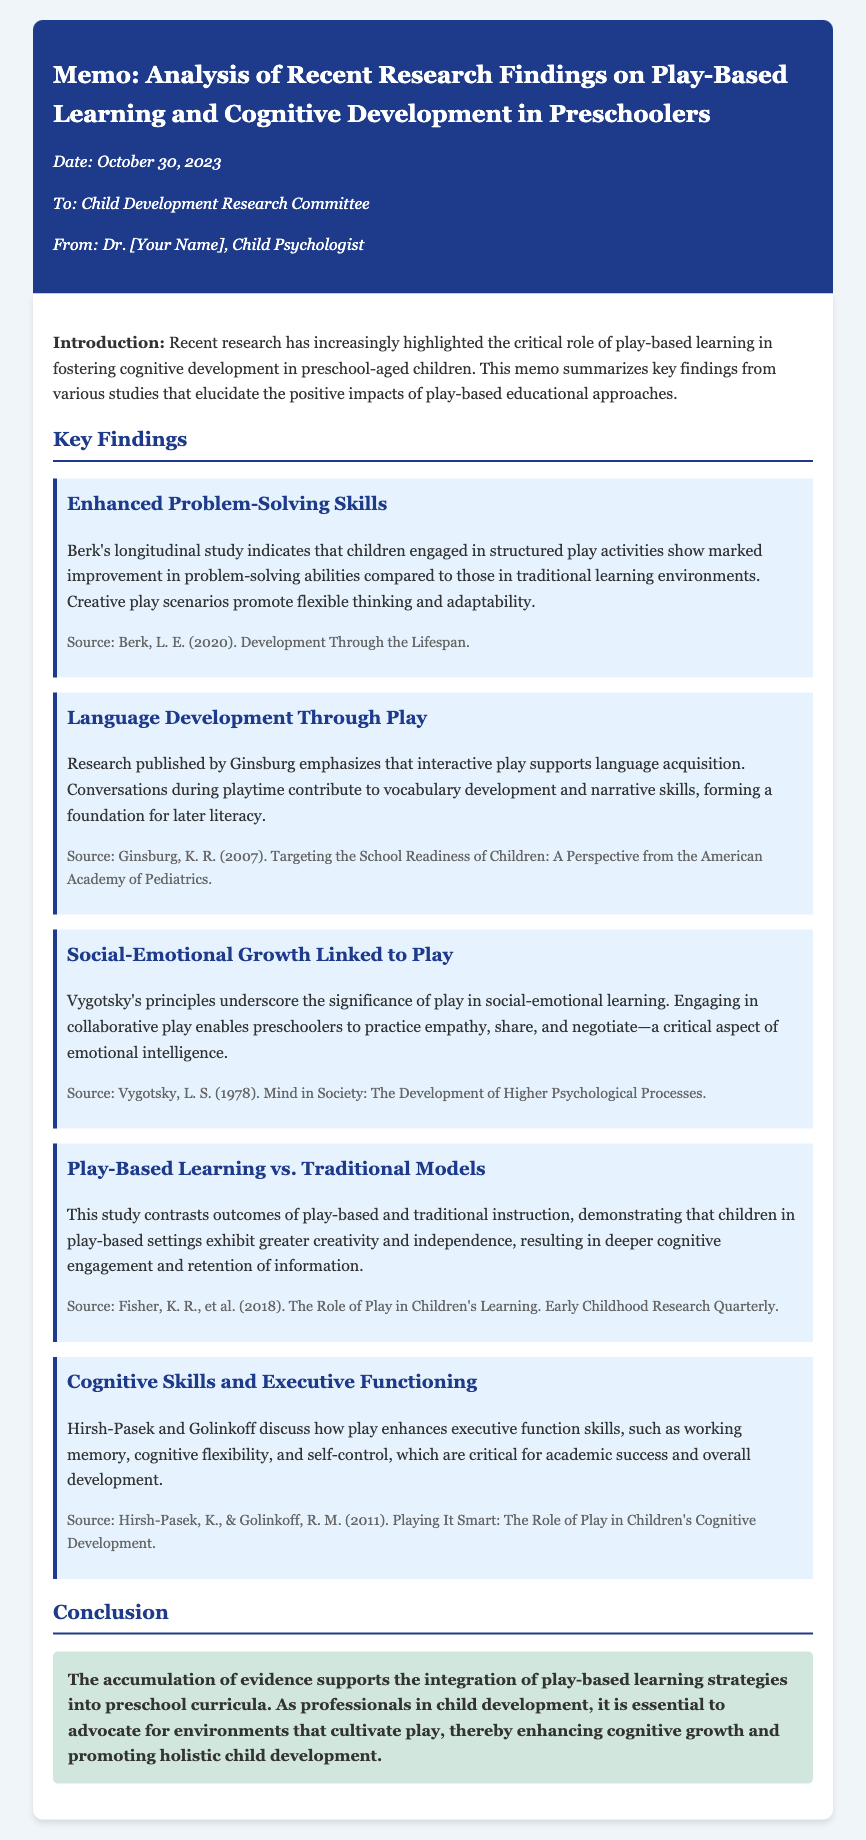What is the date of the memo? The date is mentioned in the meta-info section of the memo, which states October 30, 2023.
Answer: October 30, 2023 Who is the author of the memo? The author is listed in the meta-info section as Dr. [Your Name], Child Psychologist.
Answer: Dr. [Your Name] What is the first key finding related to play-based learning? The first key finding is under the section "Enhanced Problem-Solving Skills," which discusses children improving problem-solving abilities.
Answer: Enhanced Problem-Solving Skills Which study emphasizes language acquisition through play? The study highlighting this is by Ginsburg, as stated in the "Language Development Through Play" key finding.
Answer: Ginsburg What year was Hirsh-Pasek and Golinkoff's study published? The publication year for Hirsh-Pasek and Golinkoff's work is mentioned in the key finding section as 2011.
Answer: 2011 What is the main conclusion of the memo? The conclusion summarizes the evidence which supports integrating play-based learning strategies into preschool curricula.
Answer: Integration of play-based learning strategies What aspect of development does Vygotsky's principle focus on? Vygotsky's principles underscore the significance of play in social-emotional learning, as noted in the relevant key finding.
Answer: Social-emotional learning What does the last key finding discuss? The last key finding discusses cognitive skills and executive functioning in relation to play-based learning.
Answer: Cognitive Skills and Executive Functioning 